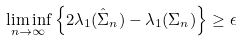<formula> <loc_0><loc_0><loc_500><loc_500>\liminf _ { n \to \infty } \left \{ 2 \lambda _ { 1 } ( \hat { \Sigma } _ { n } ) - \lambda _ { 1 } ( \Sigma _ { n } ) \right \} \geq \epsilon</formula> 